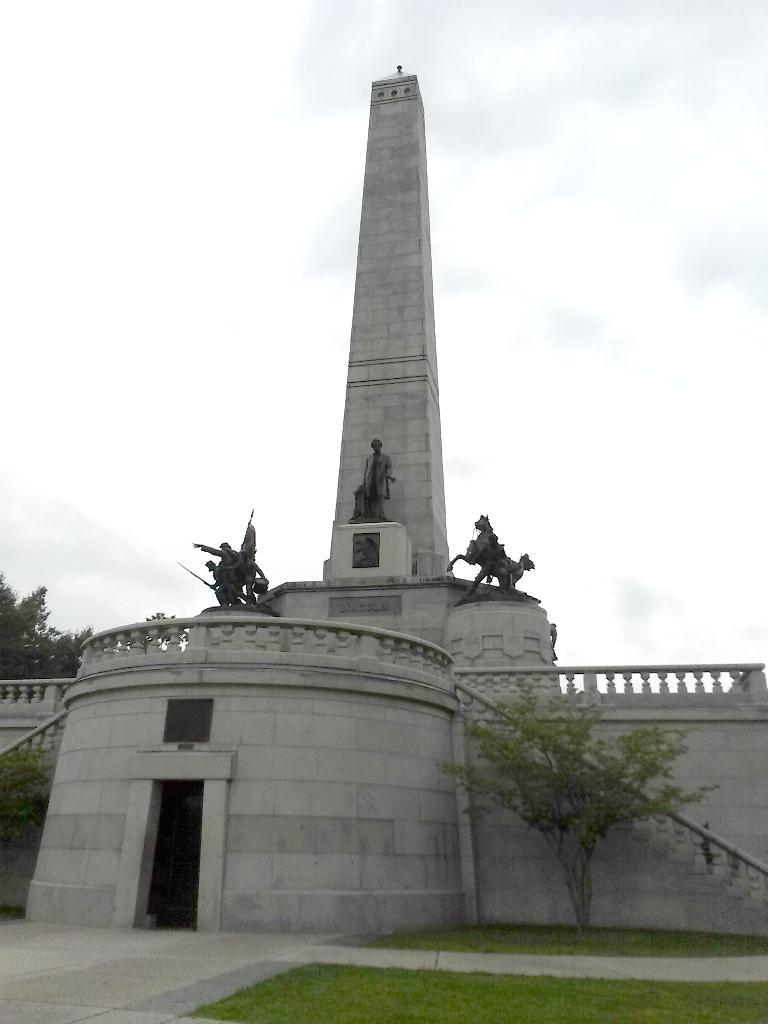What type of structure is present in the image? There is a building in the image. What other objects can be seen in the image? There are statues in the image. What is the surface that the building and statues are standing on? The ground is visible in the image. What type of vegetation is present in the image? There is grass and trees in the image. What part of the natural environment is visible in the image? The sky is visible in the image. What type of mint is growing on the branches of the trees in the image? There is no mint growing on the branches of the trees in the image; the trees are not specified as mint trees. 